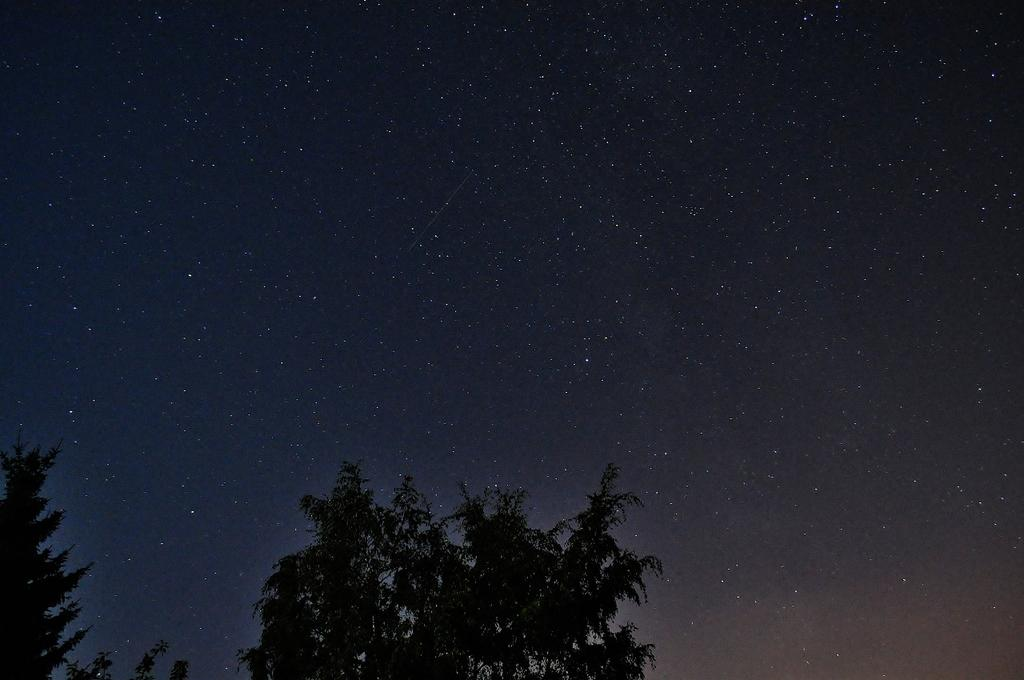What part of the natural environment can be seen in the image? The sky is visible in the image. What type of vegetation is present in the image? There are trees in the image, with their bottom parts truncated. Can you see a rat hiding under the shade of the trees in the image? There is no rat present in the image, nor is there any shade visible under the trees. 